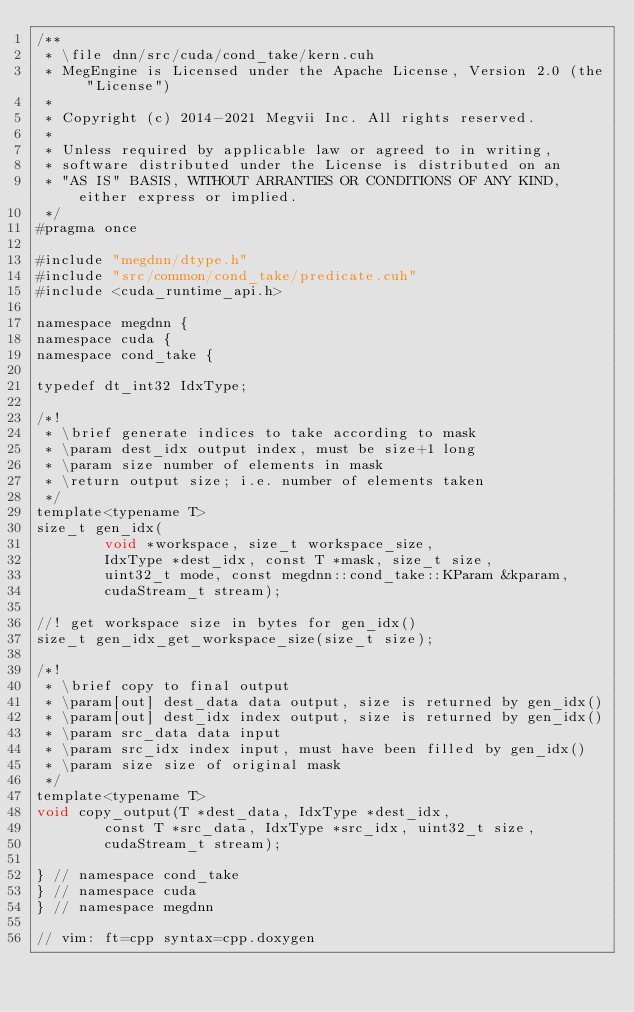<code> <loc_0><loc_0><loc_500><loc_500><_Cuda_>/**
 * \file dnn/src/cuda/cond_take/kern.cuh
 * MegEngine is Licensed under the Apache License, Version 2.0 (the "License")
 *
 * Copyright (c) 2014-2021 Megvii Inc. All rights reserved.
 *
 * Unless required by applicable law or agreed to in writing,
 * software distributed under the License is distributed on an
 * "AS IS" BASIS, WITHOUT ARRANTIES OR CONDITIONS OF ANY KIND, either express or implied.
 */
#pragma once

#include "megdnn/dtype.h"
#include "src/common/cond_take/predicate.cuh"
#include <cuda_runtime_api.h>

namespace megdnn {
namespace cuda {
namespace cond_take {

typedef dt_int32 IdxType;

/*!
 * \brief generate indices to take according to mask
 * \param dest_idx output index, must be size+1 long
 * \param size number of elements in mask
 * \return output size; i.e. number of elements taken
 */
template<typename T>
size_t gen_idx(
        void *workspace, size_t workspace_size,
        IdxType *dest_idx, const T *mask, size_t size,
        uint32_t mode, const megdnn::cond_take::KParam &kparam,
        cudaStream_t stream);

//! get workspace size in bytes for gen_idx()
size_t gen_idx_get_workspace_size(size_t size);

/*!
 * \brief copy to final output
 * \param[out] dest_data data output, size is returned by gen_idx()
 * \param[out] dest_idx index output, size is returned by gen_idx()
 * \param src_data data input
 * \param src_idx index input, must have been filled by gen_idx()
 * \param size size of original mask
 */
template<typename T>
void copy_output(T *dest_data, IdxType *dest_idx,
        const T *src_data, IdxType *src_idx, uint32_t size,
        cudaStream_t stream);

} // namespace cond_take
} // namespace cuda
} // namespace megdnn

// vim: ft=cpp syntax=cpp.doxygen
</code> 